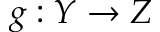Convert formula to latex. <formula><loc_0><loc_0><loc_500><loc_500>g \colon Y \to Z</formula> 